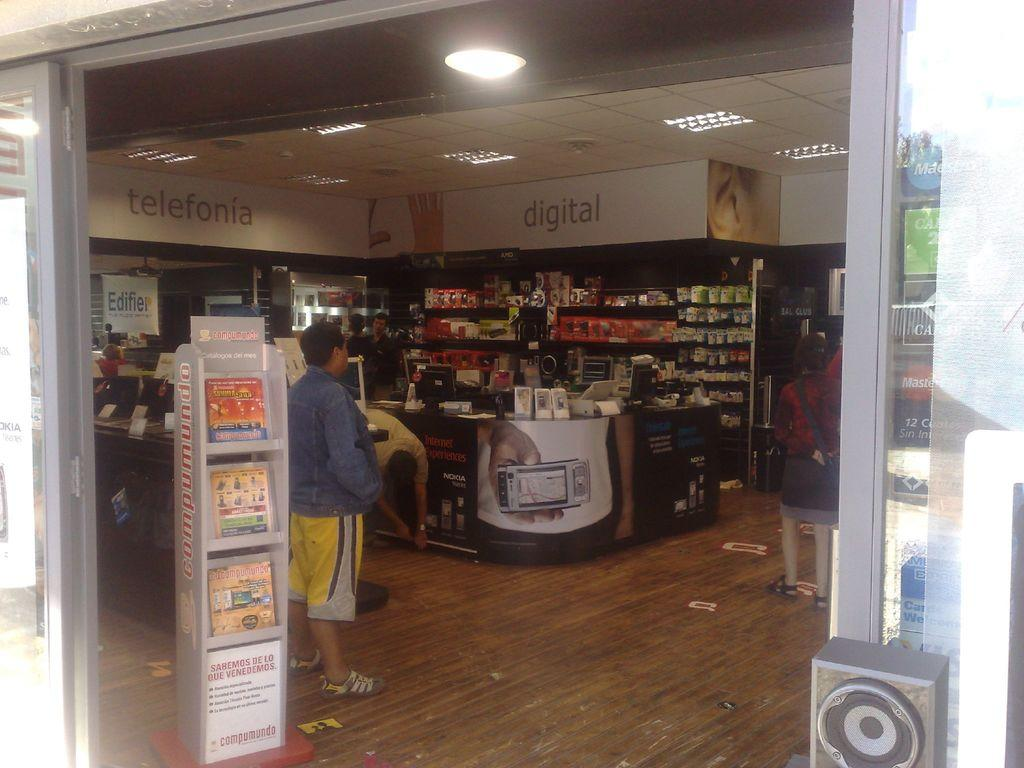<image>
Create a compact narrative representing the image presented. People shopping inside a store near the digital section. 